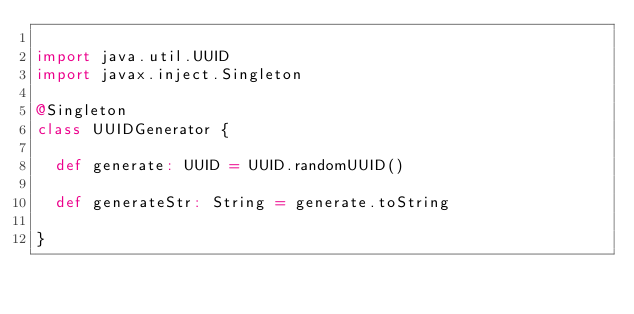Convert code to text. <code><loc_0><loc_0><loc_500><loc_500><_Scala_>
import java.util.UUID
import javax.inject.Singleton

@Singleton
class UUIDGenerator {

  def generate: UUID = UUID.randomUUID()

  def generateStr: String = generate.toString

}</code> 